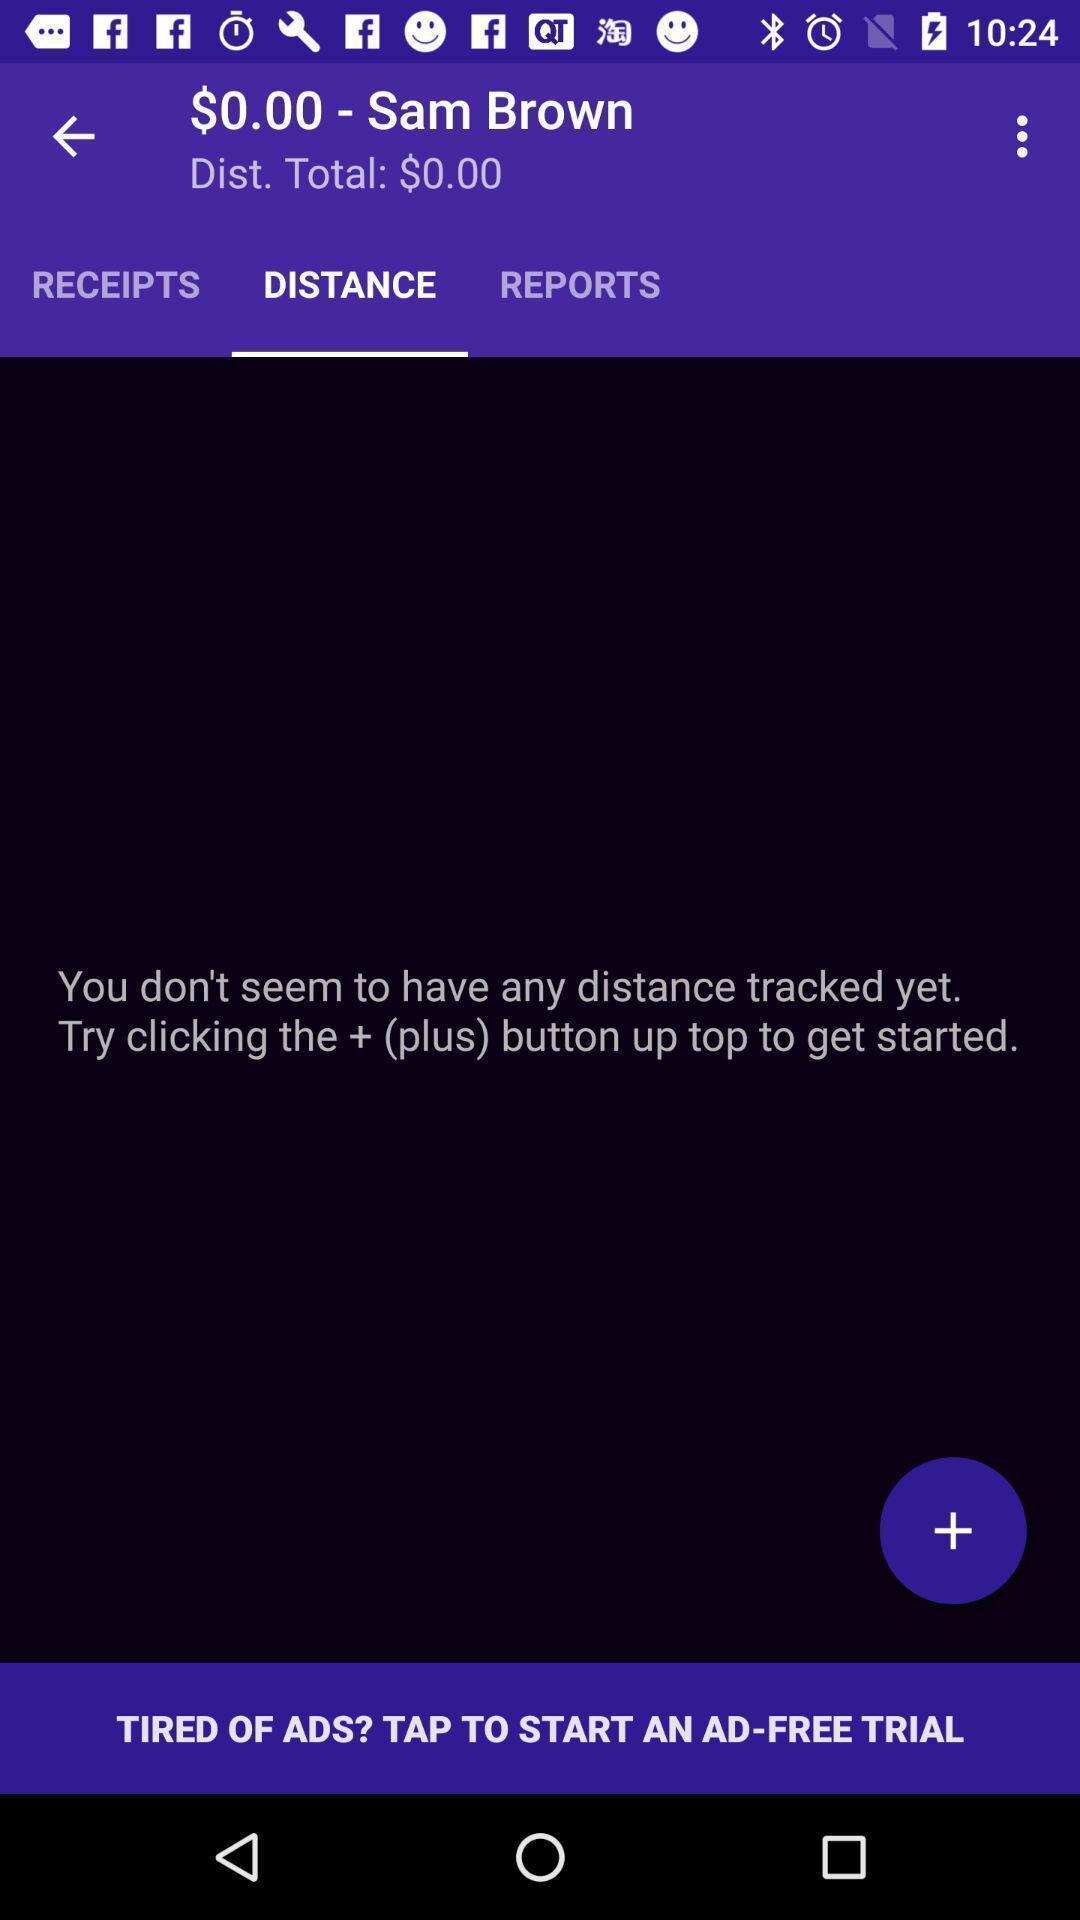Describe the content in this image. Page showing mileage tracker app. 